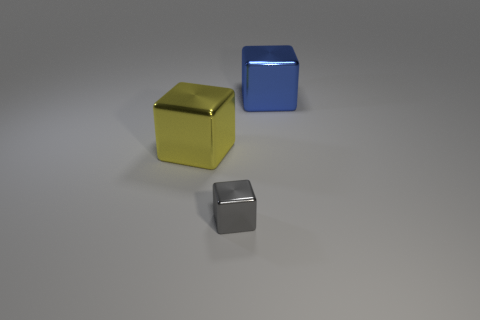Add 1 big shiny objects. How many objects exist? 4 Add 3 small gray cubes. How many small gray cubes are left? 4 Add 1 big blue shiny blocks. How many big blue shiny blocks exist? 2 Subtract 1 gray cubes. How many objects are left? 2 Subtract all small gray metallic cubes. Subtract all gray cubes. How many objects are left? 1 